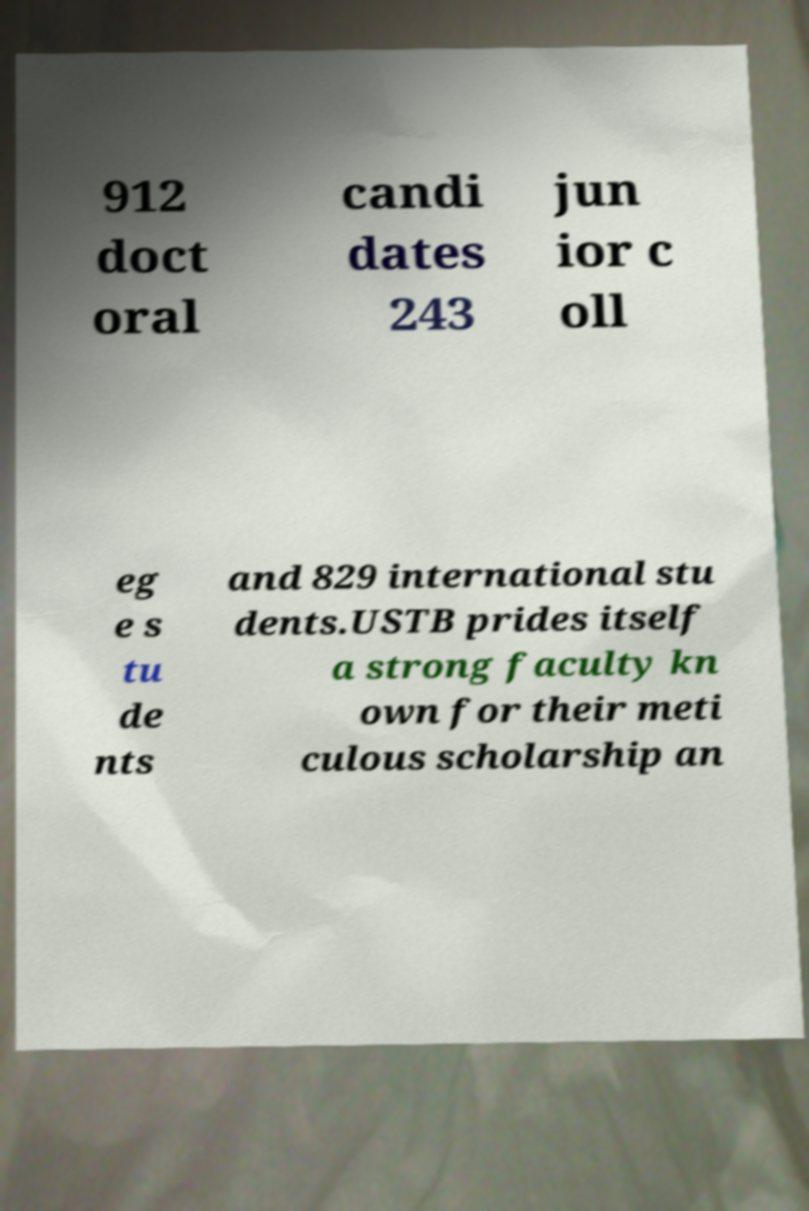Please identify and transcribe the text found in this image. 912 doct oral candi dates 243 jun ior c oll eg e s tu de nts and 829 international stu dents.USTB prides itself a strong faculty kn own for their meti culous scholarship an 